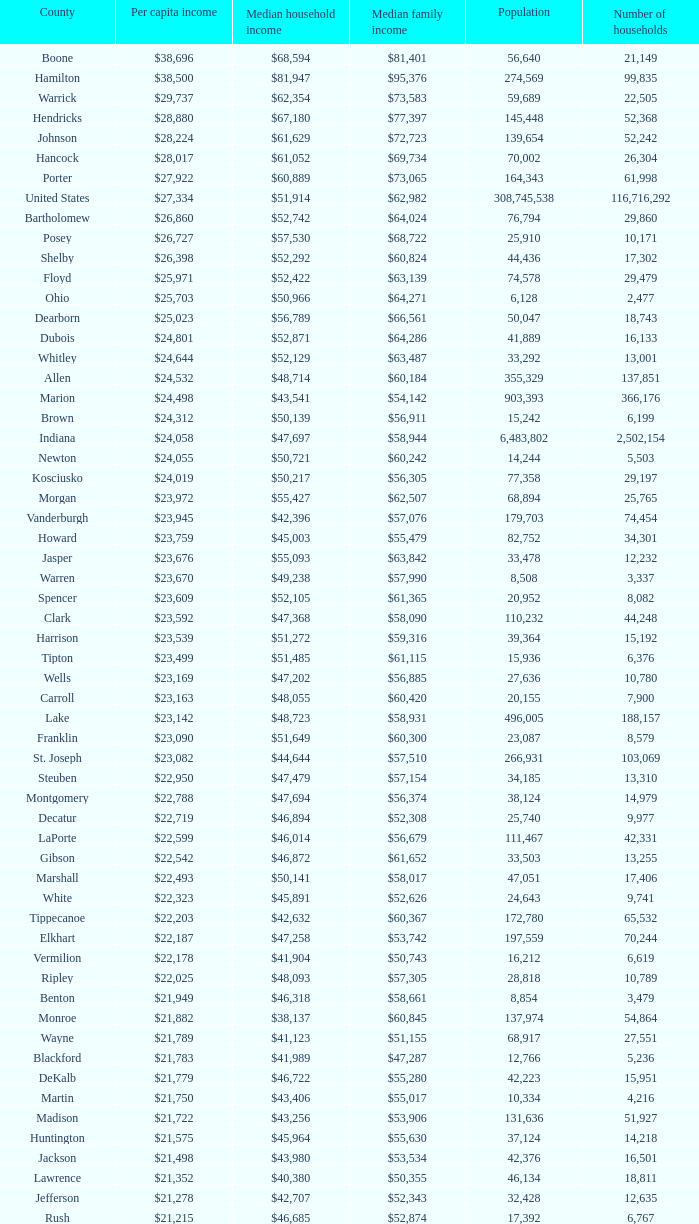What is the Median family income when the Median household income is $38,137? $60,845. 